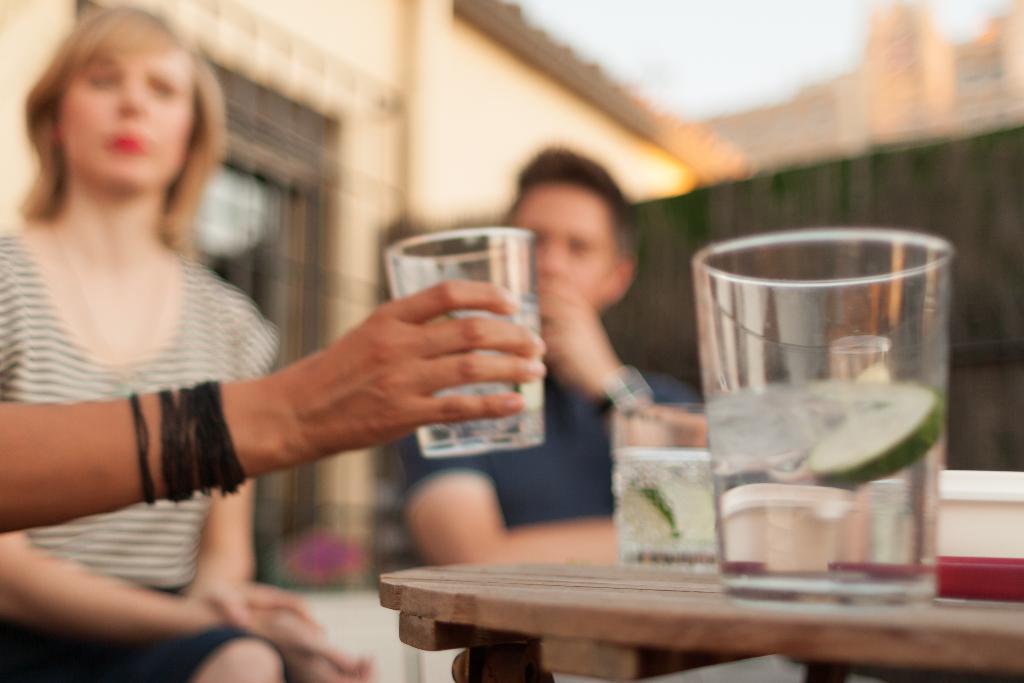Could you give a brief overview of what you see in this image? In this image a person holding a glass , a woman and man sitting in the chair a table with glass containing water and lemon and at the back ground there is a building and sky. 